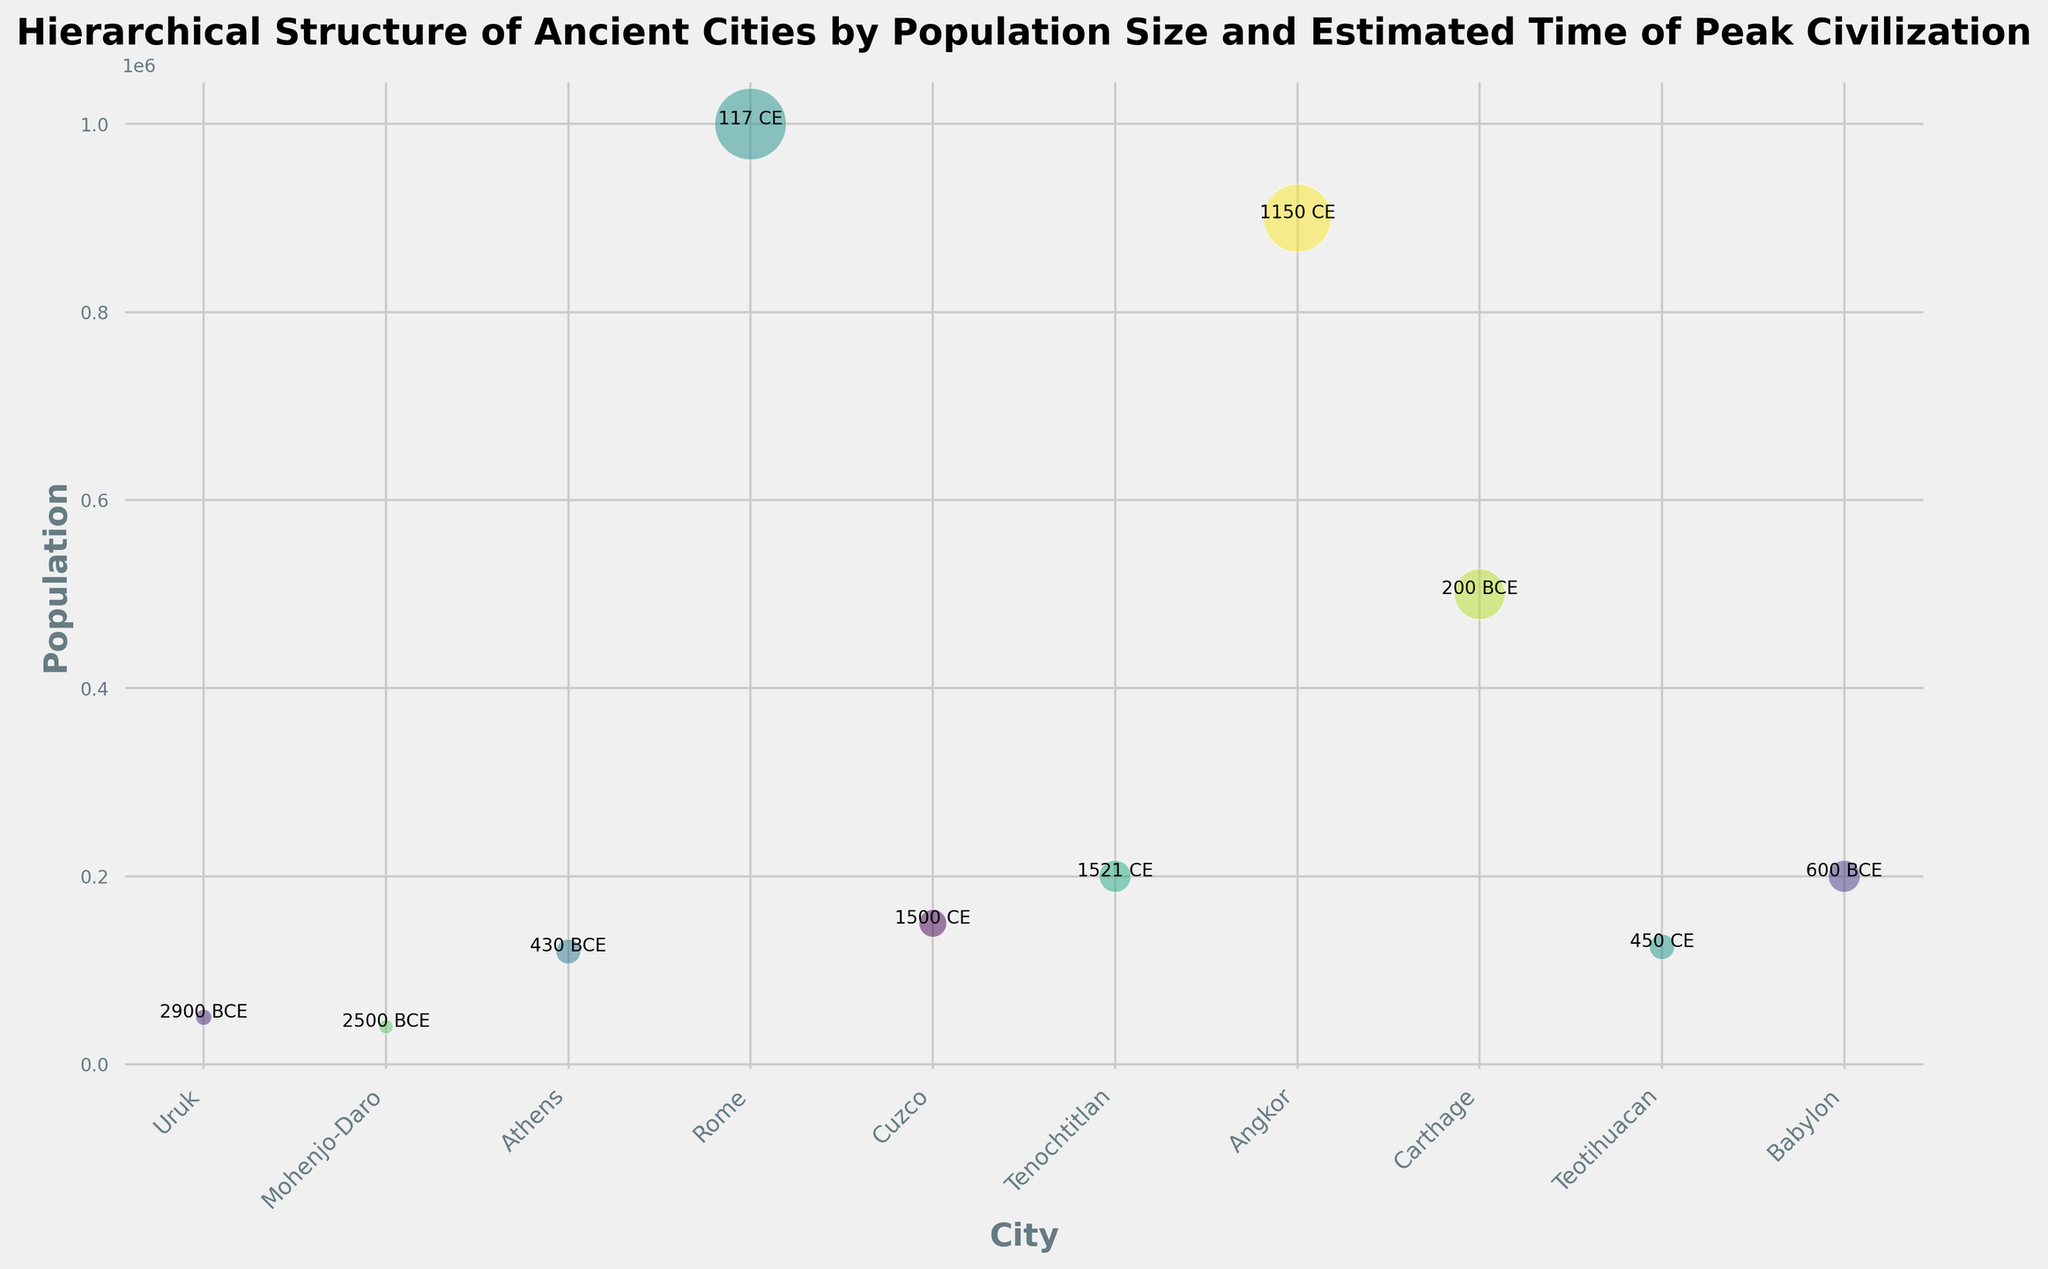What's the largest city by population? The largest city by population can be identified by looking at which bubble has the largest size. In this case, "Rome" has the largest bubble, signifying it had the biggest population.
Answer: Rome Which city had its peak civilization the earliest? The city that had its peak civilization the earliest can be identified by looking at the labels indicating the time of peak civilization. "Uruk" is marked as 2900 BCE, making it the earliest.
Answer: Uruk What's the difference in population between Athens and Teotihuacan? From the chart, Athens has a population of 120,000 and Teotihuacan has 125,000. The difference in population sizes is calculated as 125,000 - 120,000 = 5,000.
Answer: 5,000 Which cities have a population of more than 200,000? Identifying cities with populations over 200,000 involves scanning the chart for bubbles larger than this threshold and confirming via annotations. "Rome," "Carthage," and "Tenochtitlan" meet this criterion.
Answer: Rome, Carthage, Tenochtitlan Which city achieved its peak civilization last? The city that reached its peak civilization last can be found by checking the labels for the most recent date. "Cuzco" in 1500 CE is the latest peak.
Answer: Cuzco Which city has a larger population, Babylon or Cuzco? Comparing the sizes of the bubbles and the labels, Babylon has a population of 200,000 while Cuzco has 150,000, making Babylon larger.
Answer: Babylon What's the combined population of Uruk and Mohenjo-Daro? Combining the populations involves summing the two values. Uruk has 50,000 and Mohenjo-Daro has 40,000. Thus, the combined population is 50,000 + 40,000 = 90,000.
Answer: 90,000 Which city had its peak civilization around the time of 450 CE? Finding the city peak around 450 CE involves looking for the city with this exact label. "Teotihuacan" is annotated with 450 CE.
Answer: Teotihuacan What's the average population size of the cities listed? For the average population, sum all city populations and divide by the number of cities. The total population is 50,000 + 40,000 + 120,000 + 1,000,000 + 150,000 + 200,000 + 900,000 + 500,000 + 125,000 + 200,000 = 3,285,000, divided by 10 cities results in an average of 328,500.
Answer: 328,500 Which city from the list is visually represented with the smallest circle? The city with the smallest circle represents the smallest population. "Uruk" has the smallest bubble, indicating it has the smallest population of 50,000.
Answer: Uruk 